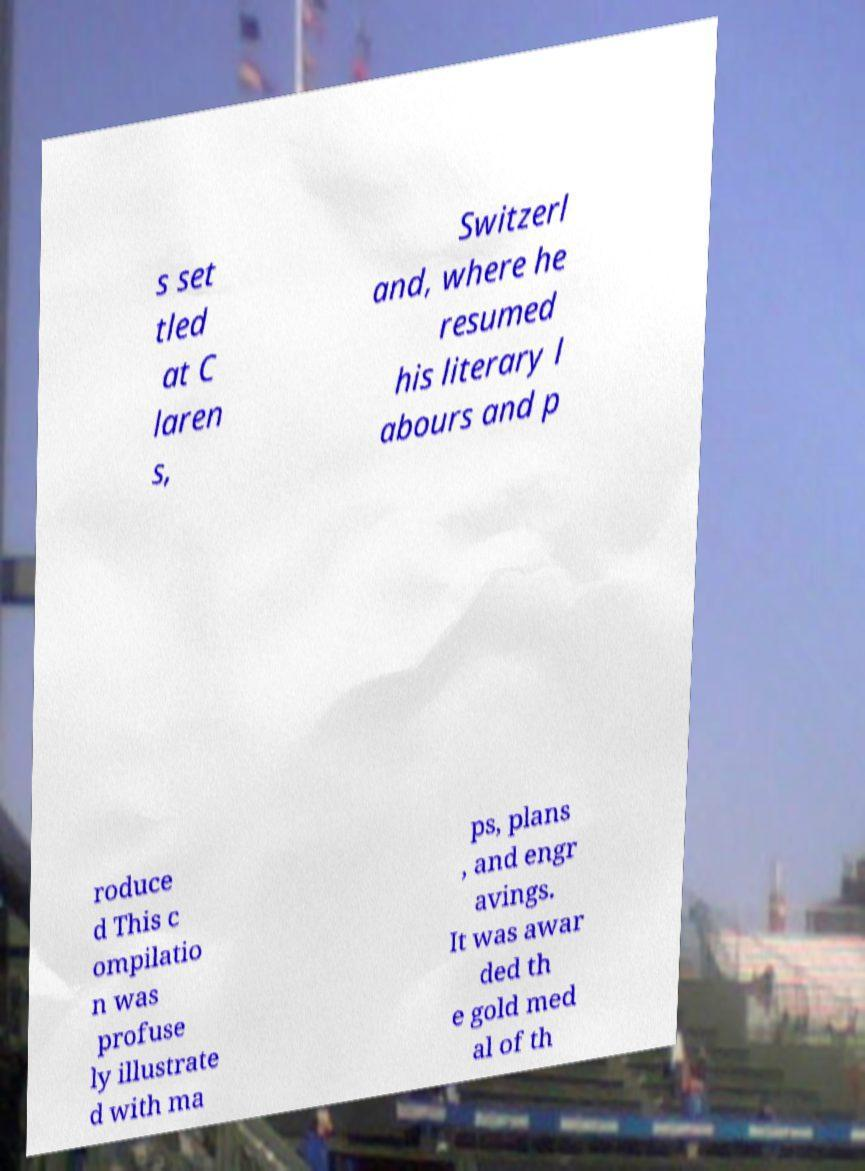I need the written content from this picture converted into text. Can you do that? s set tled at C laren s, Switzerl and, where he resumed his literary l abours and p roduce d This c ompilatio n was profuse ly illustrate d with ma ps, plans , and engr avings. It was awar ded th e gold med al of th 